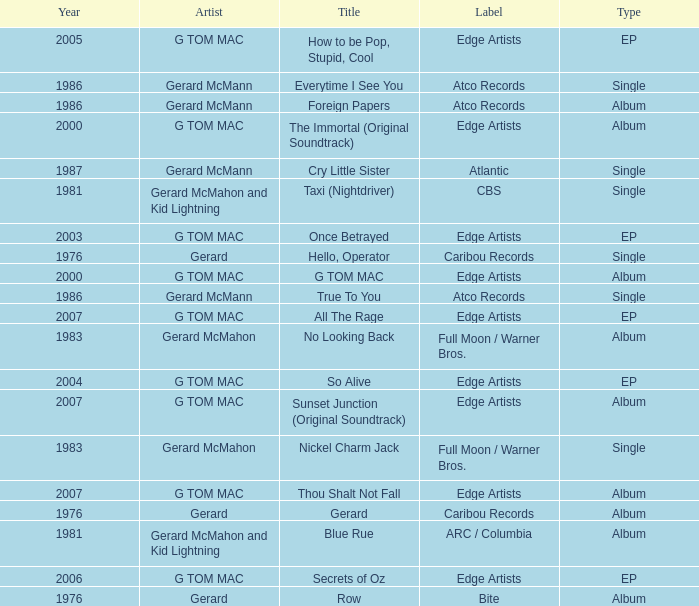Which type has a title of so alive? EP. 